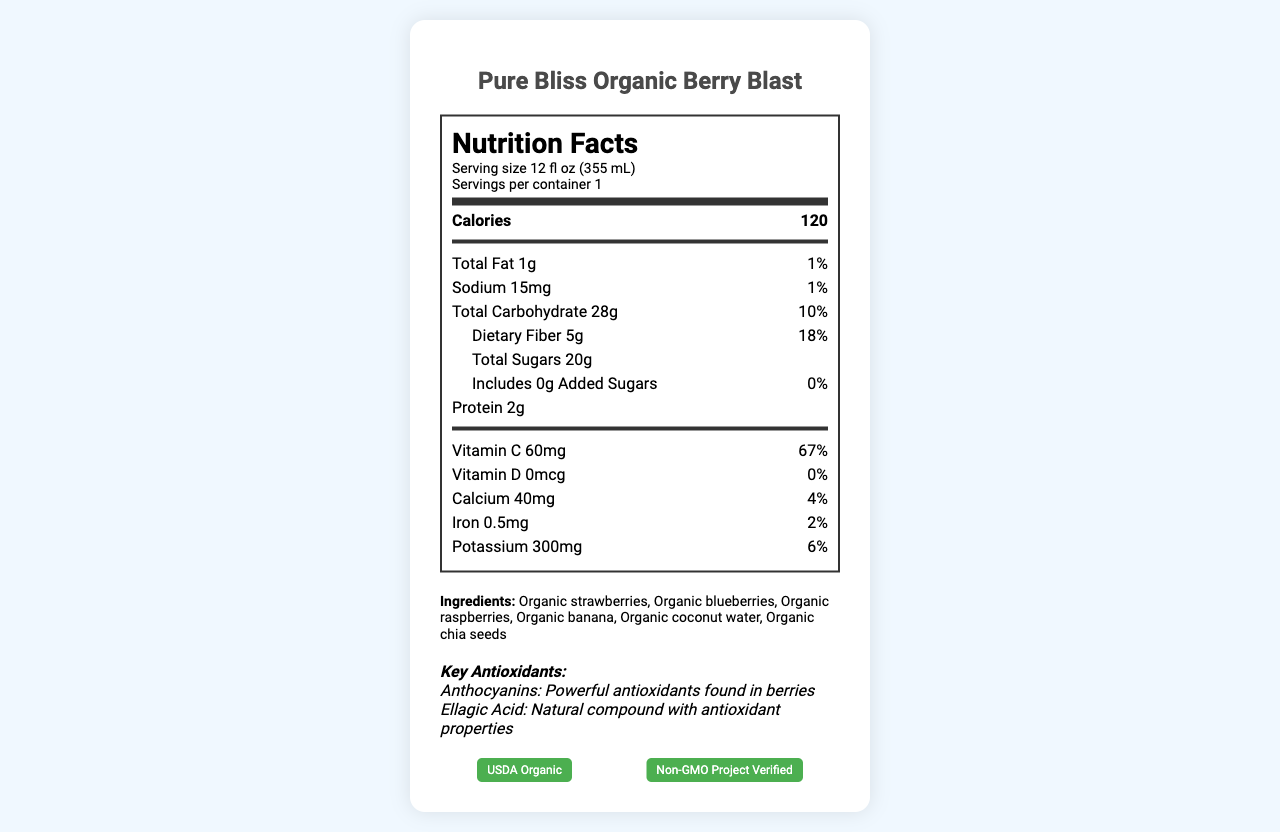how many calories are in one serving of the Pure Bliss Organic Berry Blast? The document lists the calories as 120 per serving in the Nutrition Facts section.
Answer: 120 what is the serving size for the Pure Bliss Organic Berry Blast? The serving size is mentioned at the top of the Nutrition Label: "Serving size 12 fl oz (355 mL)."
Answer: 12 fl oz (355 mL) what is the amount of dietary fiber per serving and its daily value percentage? The document indicates that there is 5g of dietary fiber per serving, which equals 18% of the daily value.
Answer: 5g, 18% are there any added sugars in the smoothie? The document explicitly states that there are 0g of added sugars, which is 0% of the daily value.
Answer: No name two key antioxidants mentioned on the label and provide their descriptions. These two antioxidants and their descriptions are listed under the "Key Antioxidants" section of the document.
Answer: Anthocyanins: Powerful antioxidants found in berries, Ellagic Acid: Natural compound with antioxidant properties what certifications does the Pure Bliss Organic Berry Blast have? A. FDA Approved B. USDA Organic C. Gluten-Free D. Non-GMO Project Verified The certifications at the bottom of the document are "USDA Organic" and "Non-GMO Project Verified."
Answer: B, D how much protein is in one serving of the smoothie? The document mentions that each serving contains 2g of protein.
Answer: 2g is there any vitamin D in the Pure Bliss Organic Berry Blast? The document lists 0mcg of vitamin D, which is 0% of the daily value.
Answer: No list all the ingredients of the Pure Bliss Organic Berry Blast. The ingredients are listed in the "Ingredients" section of the document.
Answer: Organic strawberries, Organic blueberries, Organic raspberries, Organic banana, Organic coconut water, Organic chia seeds name one allergen warning found on the label. The allergen information is listed clearly in the document as "Processed in a facility that also handles tree nuts and soy."
Answer: Processed in a facility that also handles tree nuts and soy how much iron is in one serving, and what percentage of the daily value does this represent? The document states that each serving contains 0.5mg of iron, representing 2% of the daily value.
Answer: 0.5mg, 2% did the manufacturer include a note about any potential allergen cross-contamination? A: Yes, with peanuts B: Yes, with tree nuts and soy C: No allergen cross-contamination mentioned The allergen information specifies cross-contamination with tree nuts and soy.
Answer: B does the product contain any ingredients associated with nuts? The ingredient list includes "Organic chia seeds," which are seeds but could cross-contaminate with nuts given the allergen information.
Answer: Yes cannot be determined from this document, does the Pure Bliss Organic Berry Blast contain any artificial flavors or colors? The document does not provide any information on whether the smoothie contains artificial flavors or colors.
Answer: I don't know describe the main idea of the document. The document provides a comprehensive overview of the nutritional content, ingredients, and certifications of the Pure Bliss Organic Berry Blast smoothie, aiming to inform consumers about what they are consuming.
Answer: The document is a Nutrition Facts label for the Pure Bliss Organic Berry Blast smoothie. It provides details about serving size, calories, and nutrient content, including key antioxidants and ingredients. Additionally, it highlights certifications like USDA Organic and Non-GMO Project Verified and gives allergen information. 